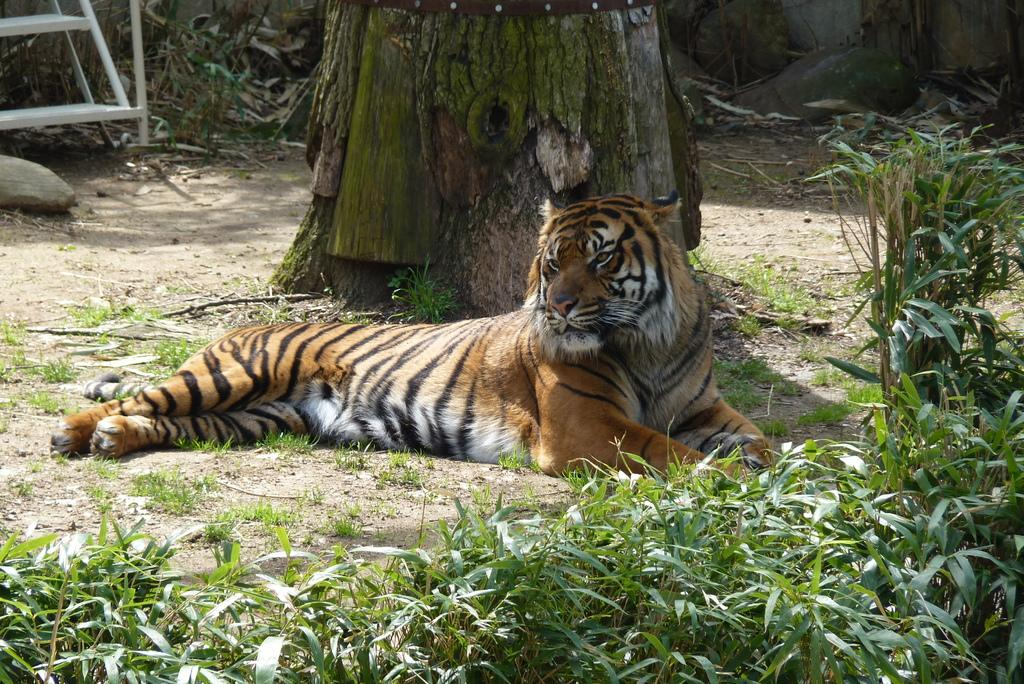What animal is laying on the ground in the image? There is a tiger laying on the ground in the image. What type of vegetation is visible in the image? There are plants visible in the image. What can be seen near the plants in the image? There is a tree trunk in the image. What architectural feature is present in the image? It appears to be a staircase in the image. What type of pet is sitting on the dinner table in the image? There is no pet or dinner table present in the image. What type of blade is being used to cut the tree trunk in the image? There is no blade or tree trunk cutting activity depicted in the image. 